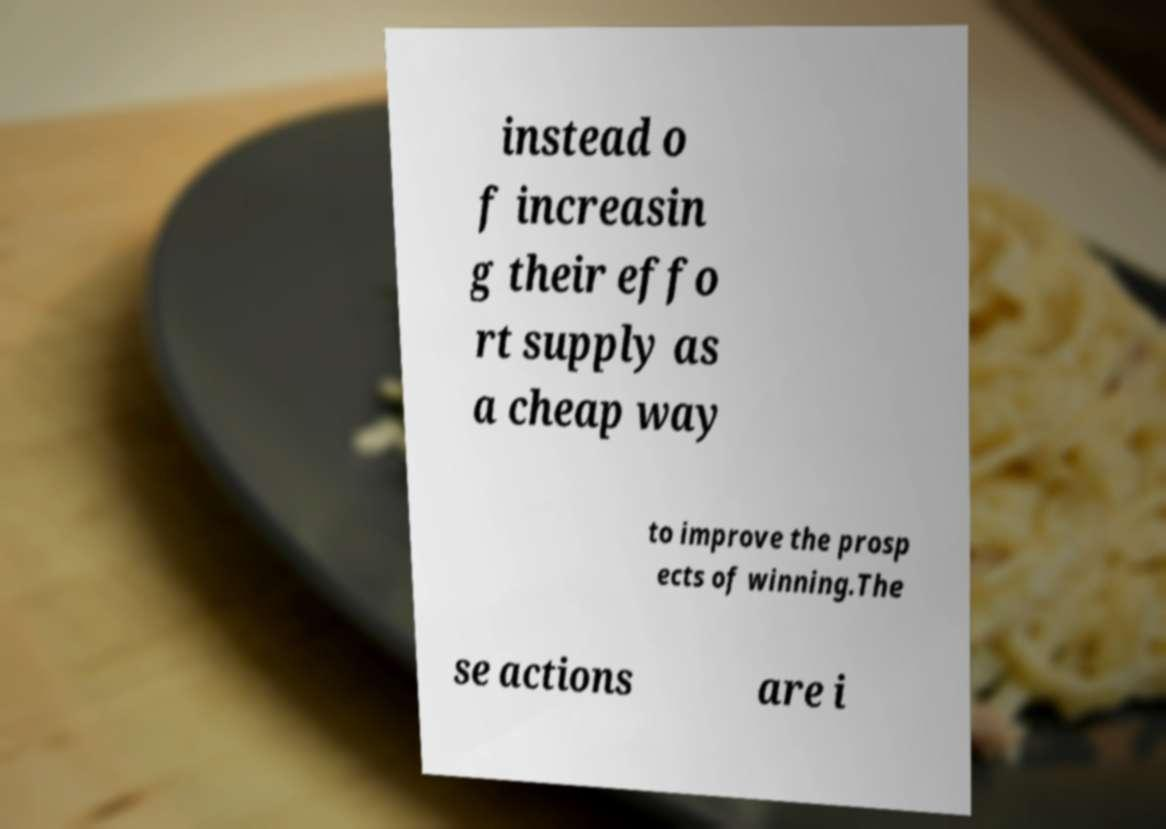Can you accurately transcribe the text from the provided image for me? instead o f increasin g their effo rt supply as a cheap way to improve the prosp ects of winning.The se actions are i 